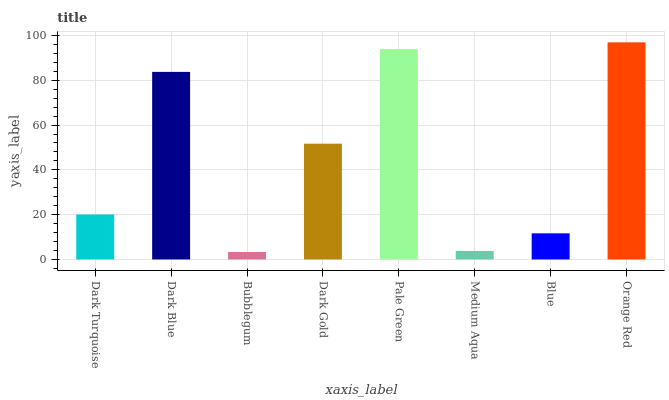Is Bubblegum the minimum?
Answer yes or no. Yes. Is Orange Red the maximum?
Answer yes or no. Yes. Is Dark Blue the minimum?
Answer yes or no. No. Is Dark Blue the maximum?
Answer yes or no. No. Is Dark Blue greater than Dark Turquoise?
Answer yes or no. Yes. Is Dark Turquoise less than Dark Blue?
Answer yes or no. Yes. Is Dark Turquoise greater than Dark Blue?
Answer yes or no. No. Is Dark Blue less than Dark Turquoise?
Answer yes or no. No. Is Dark Gold the high median?
Answer yes or no. Yes. Is Dark Turquoise the low median?
Answer yes or no. Yes. Is Pale Green the high median?
Answer yes or no. No. Is Orange Red the low median?
Answer yes or no. No. 